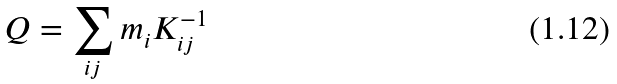Convert formula to latex. <formula><loc_0><loc_0><loc_500><loc_500>Q = \sum _ { i j } m _ { i } K ^ { - 1 } _ { i j }</formula> 